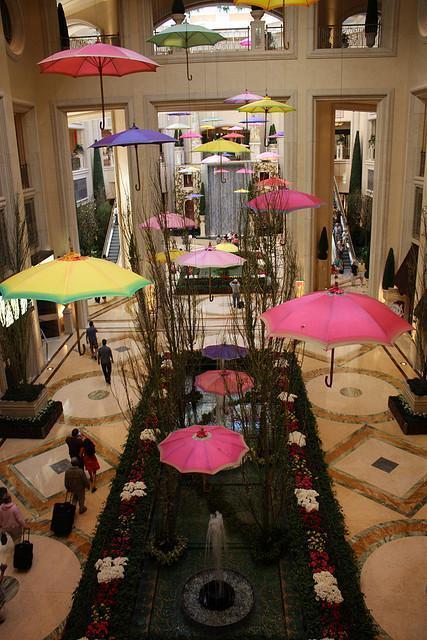How many umbrellas are there?
Give a very brief answer. 4. 